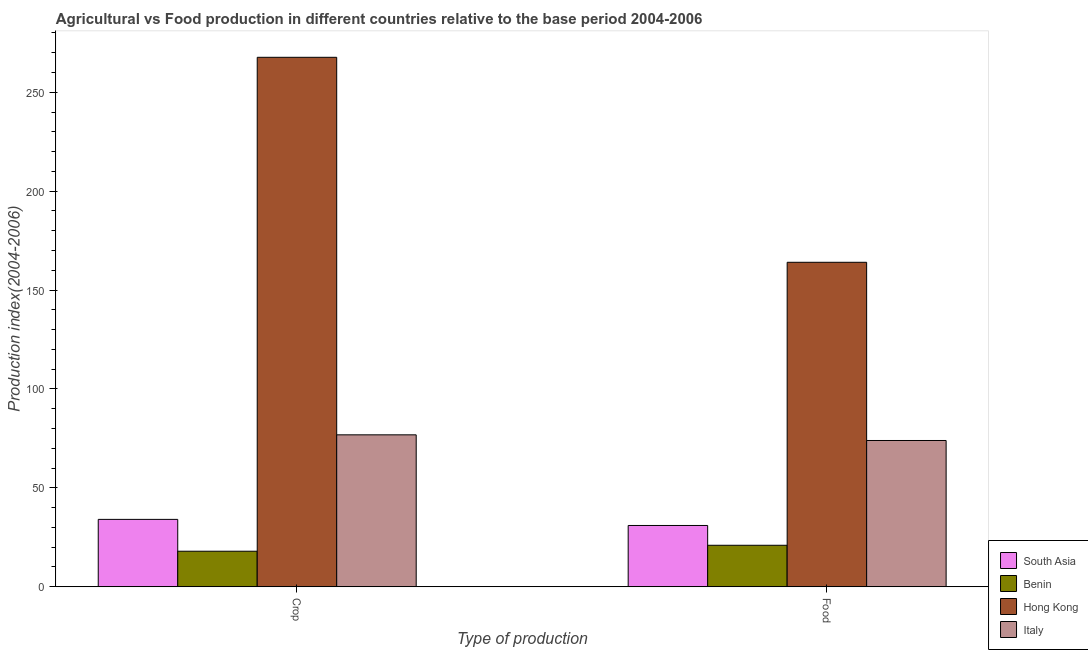Are the number of bars per tick equal to the number of legend labels?
Make the answer very short. Yes. Are the number of bars on each tick of the X-axis equal?
Your answer should be very brief. Yes. How many bars are there on the 1st tick from the left?
Ensure brevity in your answer.  4. What is the label of the 2nd group of bars from the left?
Offer a very short reply. Food. What is the food production index in South Asia?
Offer a very short reply. 30.99. Across all countries, what is the maximum food production index?
Offer a terse response. 164.05. Across all countries, what is the minimum food production index?
Your response must be concise. 20.97. In which country was the crop production index maximum?
Your response must be concise. Hong Kong. In which country was the food production index minimum?
Provide a succinct answer. Benin. What is the total crop production index in the graph?
Make the answer very short. 396.52. What is the difference between the crop production index in South Asia and that in Hong Kong?
Give a very brief answer. -233.63. What is the difference between the food production index in Italy and the crop production index in Hong Kong?
Your answer should be compact. -193.74. What is the average food production index per country?
Provide a short and direct response. 72.49. What is the difference between the crop production index and food production index in Italy?
Your answer should be compact. 2.86. In how many countries, is the food production index greater than 130 ?
Your response must be concise. 1. What is the ratio of the food production index in Hong Kong to that in South Asia?
Give a very brief answer. 5.29. Is the food production index in South Asia less than that in Italy?
Your answer should be very brief. Yes. What does the 1st bar from the left in Crop represents?
Your response must be concise. South Asia. What does the 3rd bar from the right in Crop represents?
Provide a succinct answer. Benin. How many bars are there?
Your answer should be compact. 8. Are all the bars in the graph horizontal?
Provide a succinct answer. No. Are the values on the major ticks of Y-axis written in scientific E-notation?
Your answer should be very brief. No. How are the legend labels stacked?
Give a very brief answer. Vertical. What is the title of the graph?
Offer a terse response. Agricultural vs Food production in different countries relative to the base period 2004-2006. What is the label or title of the X-axis?
Your response must be concise. Type of production. What is the label or title of the Y-axis?
Make the answer very short. Production index(2004-2006). What is the Production index(2004-2006) of South Asia in Crop?
Make the answer very short. 34.06. What is the Production index(2004-2006) in Benin in Crop?
Give a very brief answer. 17.96. What is the Production index(2004-2006) in Hong Kong in Crop?
Make the answer very short. 267.69. What is the Production index(2004-2006) of Italy in Crop?
Your response must be concise. 76.81. What is the Production index(2004-2006) in South Asia in Food?
Provide a short and direct response. 30.99. What is the Production index(2004-2006) of Benin in Food?
Give a very brief answer. 20.97. What is the Production index(2004-2006) in Hong Kong in Food?
Ensure brevity in your answer.  164.05. What is the Production index(2004-2006) of Italy in Food?
Make the answer very short. 73.95. Across all Type of production, what is the maximum Production index(2004-2006) in South Asia?
Offer a terse response. 34.06. Across all Type of production, what is the maximum Production index(2004-2006) of Benin?
Your answer should be very brief. 20.97. Across all Type of production, what is the maximum Production index(2004-2006) in Hong Kong?
Your answer should be very brief. 267.69. Across all Type of production, what is the maximum Production index(2004-2006) of Italy?
Your answer should be compact. 76.81. Across all Type of production, what is the minimum Production index(2004-2006) of South Asia?
Provide a short and direct response. 30.99. Across all Type of production, what is the minimum Production index(2004-2006) of Benin?
Your answer should be very brief. 17.96. Across all Type of production, what is the minimum Production index(2004-2006) in Hong Kong?
Give a very brief answer. 164.05. Across all Type of production, what is the minimum Production index(2004-2006) of Italy?
Provide a short and direct response. 73.95. What is the total Production index(2004-2006) of South Asia in the graph?
Your answer should be very brief. 65.05. What is the total Production index(2004-2006) in Benin in the graph?
Offer a terse response. 38.93. What is the total Production index(2004-2006) of Hong Kong in the graph?
Offer a very short reply. 431.74. What is the total Production index(2004-2006) in Italy in the graph?
Offer a terse response. 150.76. What is the difference between the Production index(2004-2006) in South Asia in Crop and that in Food?
Keep it short and to the point. 3.08. What is the difference between the Production index(2004-2006) of Benin in Crop and that in Food?
Make the answer very short. -3.01. What is the difference between the Production index(2004-2006) of Hong Kong in Crop and that in Food?
Ensure brevity in your answer.  103.64. What is the difference between the Production index(2004-2006) of Italy in Crop and that in Food?
Your response must be concise. 2.86. What is the difference between the Production index(2004-2006) in South Asia in Crop and the Production index(2004-2006) in Benin in Food?
Ensure brevity in your answer.  13.09. What is the difference between the Production index(2004-2006) in South Asia in Crop and the Production index(2004-2006) in Hong Kong in Food?
Offer a very short reply. -129.99. What is the difference between the Production index(2004-2006) in South Asia in Crop and the Production index(2004-2006) in Italy in Food?
Keep it short and to the point. -39.89. What is the difference between the Production index(2004-2006) of Benin in Crop and the Production index(2004-2006) of Hong Kong in Food?
Offer a terse response. -146.09. What is the difference between the Production index(2004-2006) in Benin in Crop and the Production index(2004-2006) in Italy in Food?
Your answer should be compact. -55.99. What is the difference between the Production index(2004-2006) of Hong Kong in Crop and the Production index(2004-2006) of Italy in Food?
Offer a very short reply. 193.74. What is the average Production index(2004-2006) of South Asia per Type of production?
Provide a short and direct response. 32.52. What is the average Production index(2004-2006) of Benin per Type of production?
Your response must be concise. 19.46. What is the average Production index(2004-2006) in Hong Kong per Type of production?
Your answer should be compact. 215.87. What is the average Production index(2004-2006) in Italy per Type of production?
Give a very brief answer. 75.38. What is the difference between the Production index(2004-2006) in South Asia and Production index(2004-2006) in Benin in Crop?
Keep it short and to the point. 16.1. What is the difference between the Production index(2004-2006) in South Asia and Production index(2004-2006) in Hong Kong in Crop?
Ensure brevity in your answer.  -233.63. What is the difference between the Production index(2004-2006) of South Asia and Production index(2004-2006) of Italy in Crop?
Provide a succinct answer. -42.75. What is the difference between the Production index(2004-2006) of Benin and Production index(2004-2006) of Hong Kong in Crop?
Provide a short and direct response. -249.73. What is the difference between the Production index(2004-2006) of Benin and Production index(2004-2006) of Italy in Crop?
Your response must be concise. -58.85. What is the difference between the Production index(2004-2006) of Hong Kong and Production index(2004-2006) of Italy in Crop?
Keep it short and to the point. 190.88. What is the difference between the Production index(2004-2006) of South Asia and Production index(2004-2006) of Benin in Food?
Your answer should be very brief. 10.02. What is the difference between the Production index(2004-2006) of South Asia and Production index(2004-2006) of Hong Kong in Food?
Your answer should be compact. -133.06. What is the difference between the Production index(2004-2006) in South Asia and Production index(2004-2006) in Italy in Food?
Give a very brief answer. -42.96. What is the difference between the Production index(2004-2006) in Benin and Production index(2004-2006) in Hong Kong in Food?
Offer a terse response. -143.08. What is the difference between the Production index(2004-2006) in Benin and Production index(2004-2006) in Italy in Food?
Provide a succinct answer. -52.98. What is the difference between the Production index(2004-2006) of Hong Kong and Production index(2004-2006) of Italy in Food?
Make the answer very short. 90.1. What is the ratio of the Production index(2004-2006) of South Asia in Crop to that in Food?
Make the answer very short. 1.1. What is the ratio of the Production index(2004-2006) in Benin in Crop to that in Food?
Your answer should be compact. 0.86. What is the ratio of the Production index(2004-2006) of Hong Kong in Crop to that in Food?
Your response must be concise. 1.63. What is the ratio of the Production index(2004-2006) in Italy in Crop to that in Food?
Offer a terse response. 1.04. What is the difference between the highest and the second highest Production index(2004-2006) of South Asia?
Offer a terse response. 3.08. What is the difference between the highest and the second highest Production index(2004-2006) of Benin?
Your answer should be very brief. 3.01. What is the difference between the highest and the second highest Production index(2004-2006) of Hong Kong?
Give a very brief answer. 103.64. What is the difference between the highest and the second highest Production index(2004-2006) in Italy?
Provide a short and direct response. 2.86. What is the difference between the highest and the lowest Production index(2004-2006) in South Asia?
Offer a very short reply. 3.08. What is the difference between the highest and the lowest Production index(2004-2006) of Benin?
Your response must be concise. 3.01. What is the difference between the highest and the lowest Production index(2004-2006) of Hong Kong?
Keep it short and to the point. 103.64. What is the difference between the highest and the lowest Production index(2004-2006) of Italy?
Provide a succinct answer. 2.86. 